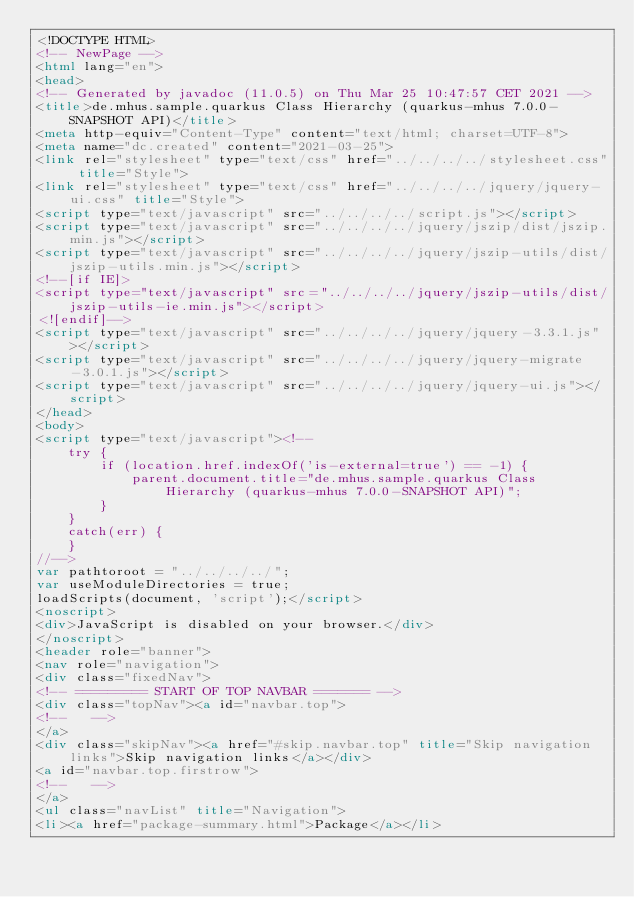Convert code to text. <code><loc_0><loc_0><loc_500><loc_500><_HTML_><!DOCTYPE HTML>
<!-- NewPage -->
<html lang="en">
<head>
<!-- Generated by javadoc (11.0.5) on Thu Mar 25 10:47:57 CET 2021 -->
<title>de.mhus.sample.quarkus Class Hierarchy (quarkus-mhus 7.0.0-SNAPSHOT API)</title>
<meta http-equiv="Content-Type" content="text/html; charset=UTF-8">
<meta name="dc.created" content="2021-03-25">
<link rel="stylesheet" type="text/css" href="../../../../stylesheet.css" title="Style">
<link rel="stylesheet" type="text/css" href="../../../../jquery/jquery-ui.css" title="Style">
<script type="text/javascript" src="../../../../script.js"></script>
<script type="text/javascript" src="../../../../jquery/jszip/dist/jszip.min.js"></script>
<script type="text/javascript" src="../../../../jquery/jszip-utils/dist/jszip-utils.min.js"></script>
<!--[if IE]>
<script type="text/javascript" src="../../../../jquery/jszip-utils/dist/jszip-utils-ie.min.js"></script>
<![endif]-->
<script type="text/javascript" src="../../../../jquery/jquery-3.3.1.js"></script>
<script type="text/javascript" src="../../../../jquery/jquery-migrate-3.0.1.js"></script>
<script type="text/javascript" src="../../../../jquery/jquery-ui.js"></script>
</head>
<body>
<script type="text/javascript"><!--
    try {
        if (location.href.indexOf('is-external=true') == -1) {
            parent.document.title="de.mhus.sample.quarkus Class Hierarchy (quarkus-mhus 7.0.0-SNAPSHOT API)";
        }
    }
    catch(err) {
    }
//-->
var pathtoroot = "../../../../";
var useModuleDirectories = true;
loadScripts(document, 'script');</script>
<noscript>
<div>JavaScript is disabled on your browser.</div>
</noscript>
<header role="banner">
<nav role="navigation">
<div class="fixedNav">
<!-- ========= START OF TOP NAVBAR ======= -->
<div class="topNav"><a id="navbar.top">
<!--   -->
</a>
<div class="skipNav"><a href="#skip.navbar.top" title="Skip navigation links">Skip navigation links</a></div>
<a id="navbar.top.firstrow">
<!--   -->
</a>
<ul class="navList" title="Navigation">
<li><a href="package-summary.html">Package</a></li></code> 